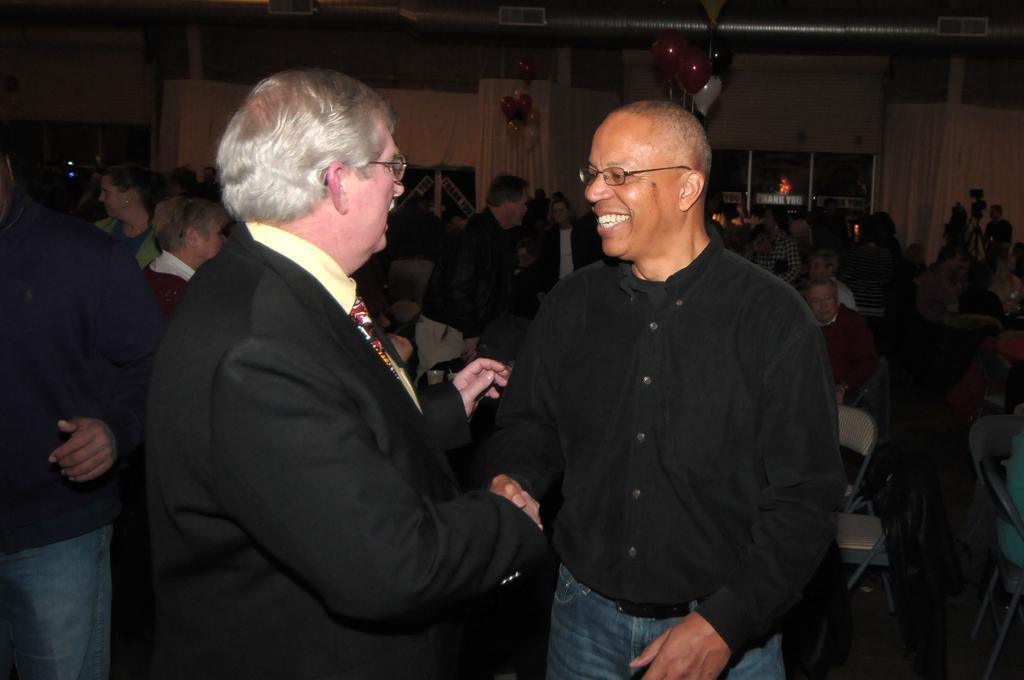Describe this image in one or two sentences. This picture seems to be clicked inside the hall. In the foreground we can see the two persons, standing and shaking their hands. In the background we can see the group of persons and we can see the chairs and the group of persons sitting on the chairs and we can see the curtains, balloons, duct and many other objects. 